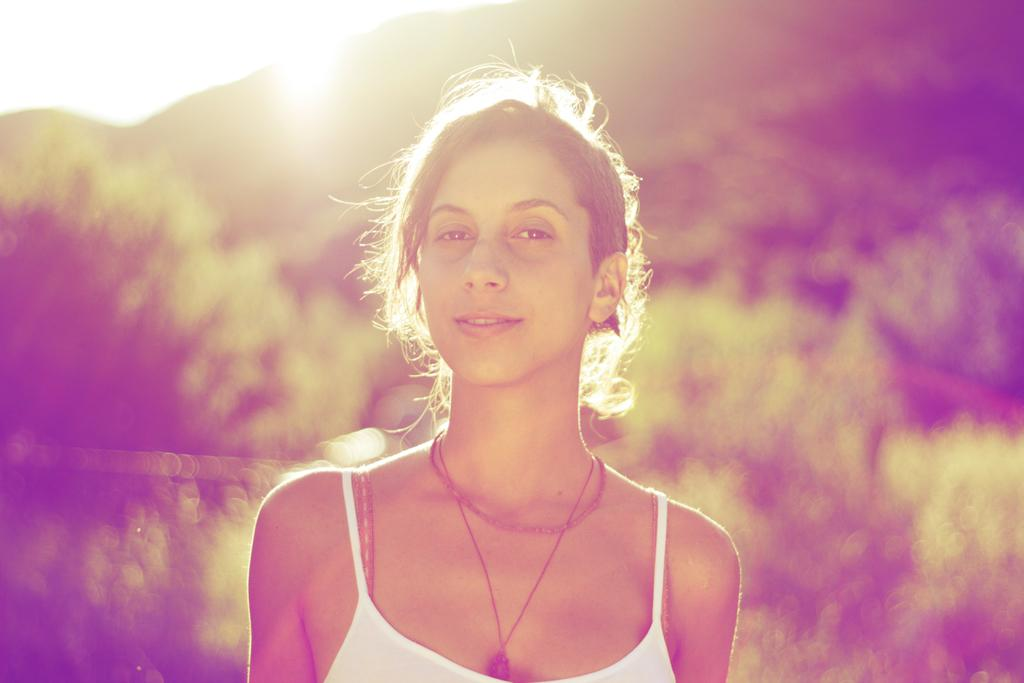What is the main subject of the image? The main subject of the image is a woman. Can you describe the background of the image? The background of the image is blurred. What type of pancake is the woman holding in the image? There is no pancake present in the image. How many cushions are visible in the image? There are no cushions visible in the image. 